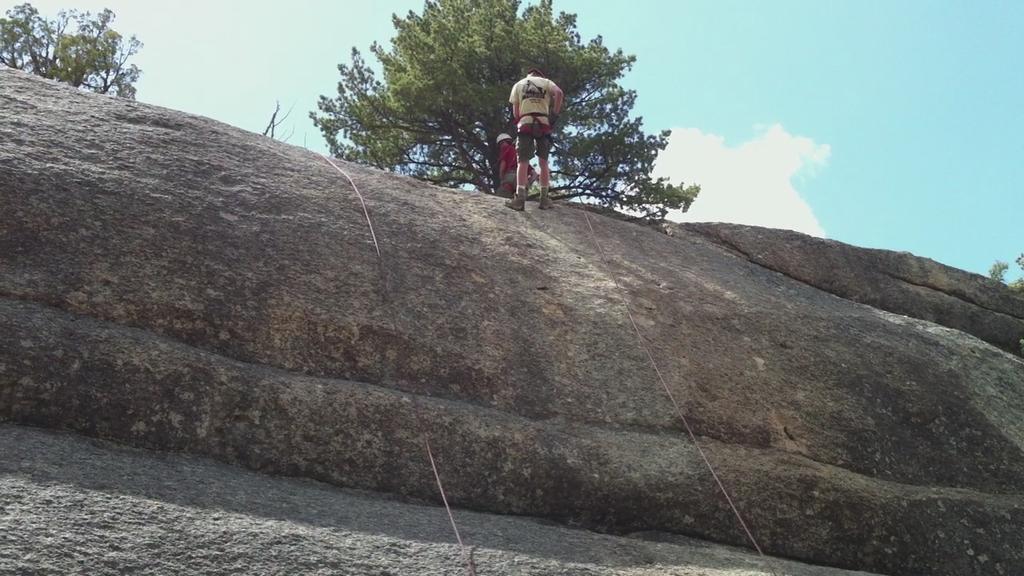Please provide a concise description of this image. In this picture we can see two persons on the rock, ropes, trees and in the background we can see the sky with clouds. 